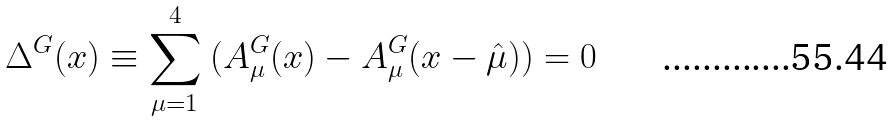<formula> <loc_0><loc_0><loc_500><loc_500>\Delta ^ { G } ( x ) \equiv \sum _ { \mu = 1 } ^ { 4 } \ ( A ^ { G } _ { \mu } ( x ) - A ^ { G } _ { \mu } ( x - \hat { \mu } ) ) = 0</formula> 